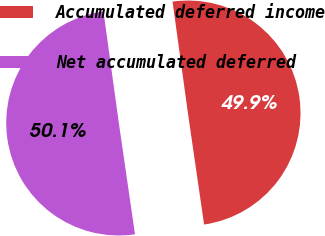Convert chart. <chart><loc_0><loc_0><loc_500><loc_500><pie_chart><fcel>Accumulated deferred income<fcel>Net accumulated deferred<nl><fcel>49.89%<fcel>50.11%<nl></chart> 